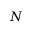<formula> <loc_0><loc_0><loc_500><loc_500>N</formula> 